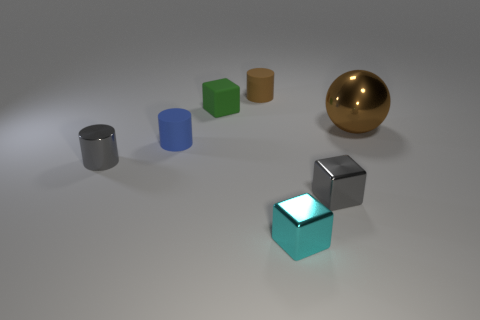Are any small purple shiny cubes visible?
Make the answer very short. No. The cylinder that is right of the tiny cube that is on the left side of the cyan cube is what color?
Offer a very short reply. Brown. What material is the tiny gray object that is the same shape as the green object?
Keep it short and to the point. Metal. What number of gray objects are the same size as the green cube?
Offer a very short reply. 2. What is the size of the cylinder that is made of the same material as the brown ball?
Keep it short and to the point. Small. What number of other blue matte objects have the same shape as the blue matte thing?
Your answer should be compact. 0. How many small brown matte objects are there?
Your answer should be compact. 1. Does the brown object that is in front of the small brown matte thing have the same shape as the green matte object?
Make the answer very short. No. There is a cyan thing that is the same size as the green matte cube; what is it made of?
Your answer should be very brief. Metal. Are there any brown spheres made of the same material as the small green cube?
Make the answer very short. No. 